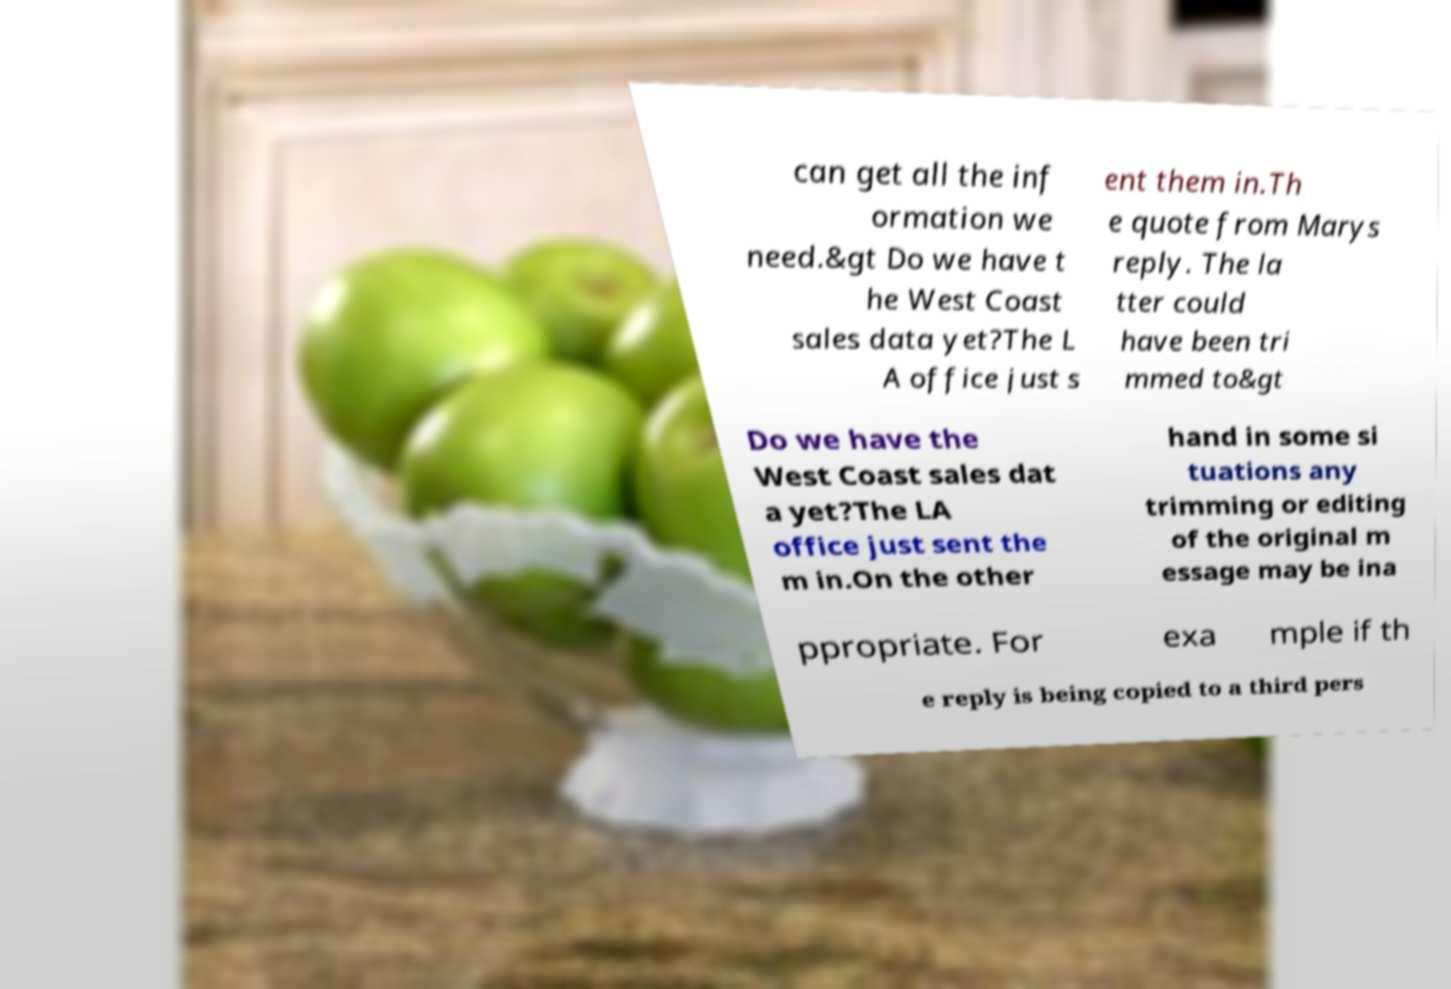Please read and relay the text visible in this image. What does it say? can get all the inf ormation we need.&gt Do we have t he West Coast sales data yet?The L A office just s ent them in.Th e quote from Marys reply. The la tter could have been tri mmed to&gt Do we have the West Coast sales dat a yet?The LA office just sent the m in.On the other hand in some si tuations any trimming or editing of the original m essage may be ina ppropriate. For exa mple if th e reply is being copied to a third pers 